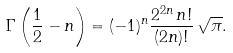<formula> <loc_0><loc_0><loc_500><loc_500>\Gamma \left ( \frac { 1 } { 2 } - n \right ) = ( - 1 ) ^ { n } \frac { 2 ^ { 2 n } \, n ! } { ( 2 n ) ! } \, \sqrt { \pi } .</formula> 